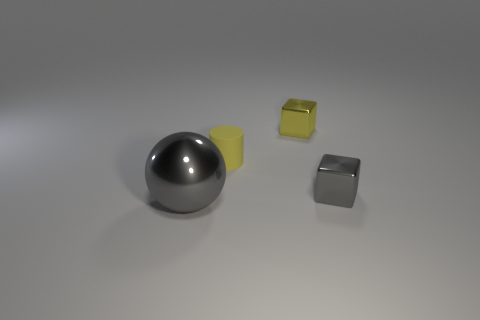How big is the rubber cylinder? The rubber cylinder appears to be small, roughly about one-quarter the size of the spherical object next to it, which offers a helpful size reference for comparison. Based on the visual cues and assuming the objects are at similar distances from the viewpoint, the cylinder's size suggests it could be comfortably held in one hand. 